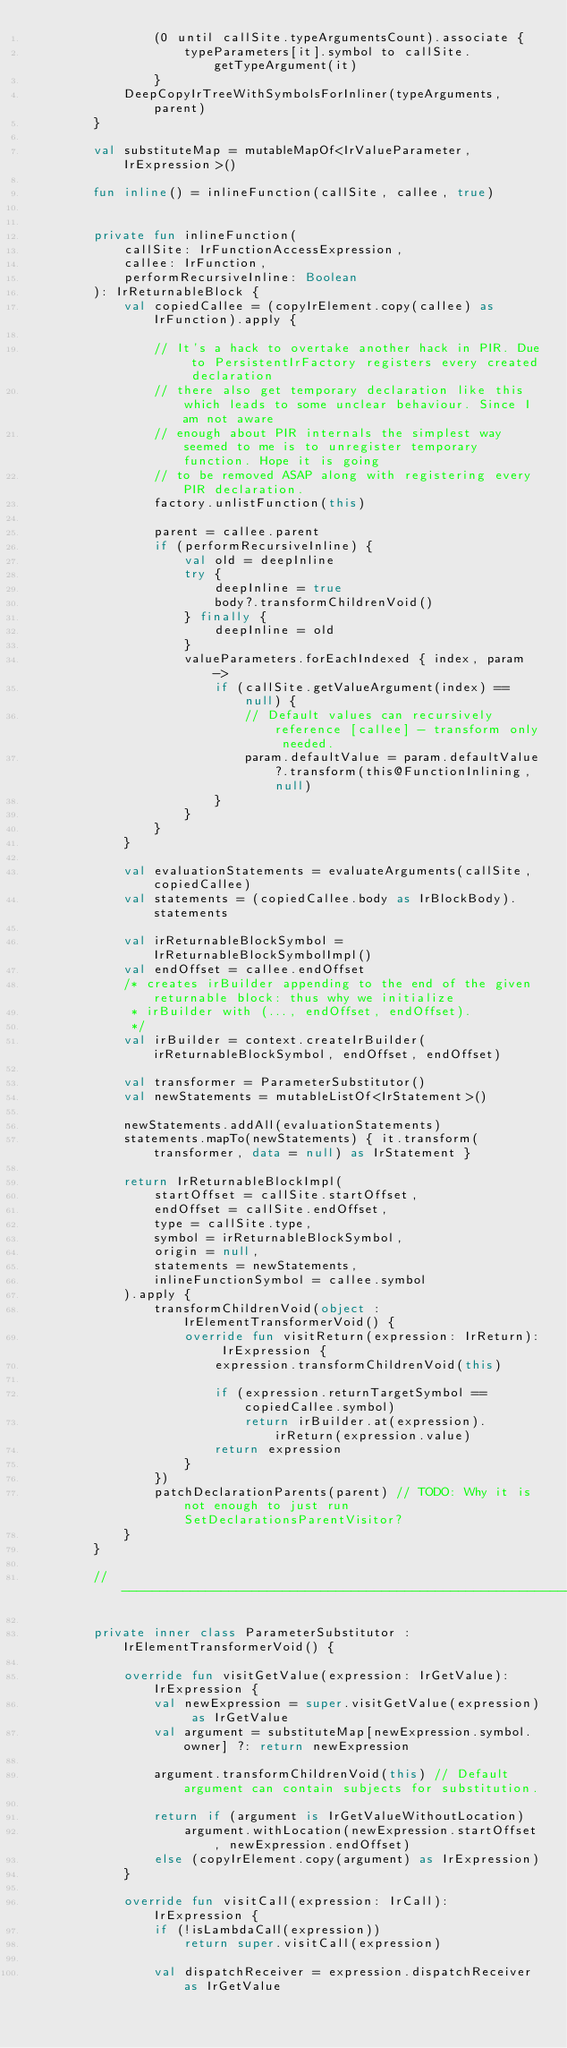Convert code to text. <code><loc_0><loc_0><loc_500><loc_500><_Kotlin_>                (0 until callSite.typeArgumentsCount).associate {
                    typeParameters[it].symbol to callSite.getTypeArgument(it)
                }
            DeepCopyIrTreeWithSymbolsForInliner(typeArguments, parent)
        }

        val substituteMap = mutableMapOf<IrValueParameter, IrExpression>()

        fun inline() = inlineFunction(callSite, callee, true)


        private fun inlineFunction(
            callSite: IrFunctionAccessExpression,
            callee: IrFunction,
            performRecursiveInline: Boolean
        ): IrReturnableBlock {
            val copiedCallee = (copyIrElement.copy(callee) as IrFunction).apply {

                // It's a hack to overtake another hack in PIR. Due to PersistentIrFactory registers every created declaration
                // there also get temporary declaration like this which leads to some unclear behaviour. Since I am not aware
                // enough about PIR internals the simplest way seemed to me is to unregister temporary function. Hope it is going
                // to be removed ASAP along with registering every PIR declaration.
                factory.unlistFunction(this)

                parent = callee.parent
                if (performRecursiveInline) {
                    val old = deepInline
                    try {
                        deepInline = true
                        body?.transformChildrenVoid()
                    } finally {
                        deepInline = old
                    }
                    valueParameters.forEachIndexed { index, param ->
                        if (callSite.getValueArgument(index) == null) {
                            // Default values can recursively reference [callee] - transform only needed.
                            param.defaultValue = param.defaultValue?.transform(this@FunctionInlining, null)
                        }
                    }
                }
            }

            val evaluationStatements = evaluateArguments(callSite, copiedCallee)
            val statements = (copiedCallee.body as IrBlockBody).statements

            val irReturnableBlockSymbol = IrReturnableBlockSymbolImpl()
            val endOffset = callee.endOffset
            /* creates irBuilder appending to the end of the given returnable block: thus why we initialize
             * irBuilder with (..., endOffset, endOffset).
             */
            val irBuilder = context.createIrBuilder(irReturnableBlockSymbol, endOffset, endOffset)

            val transformer = ParameterSubstitutor()
            val newStatements = mutableListOf<IrStatement>()

            newStatements.addAll(evaluationStatements)
            statements.mapTo(newStatements) { it.transform(transformer, data = null) as IrStatement }

            return IrReturnableBlockImpl(
                startOffset = callSite.startOffset,
                endOffset = callSite.endOffset,
                type = callSite.type,
                symbol = irReturnableBlockSymbol,
                origin = null,
                statements = newStatements,
                inlineFunctionSymbol = callee.symbol
            ).apply {
                transformChildrenVoid(object : IrElementTransformerVoid() {
                    override fun visitReturn(expression: IrReturn): IrExpression {
                        expression.transformChildrenVoid(this)

                        if (expression.returnTargetSymbol == copiedCallee.symbol)
                            return irBuilder.at(expression).irReturn(expression.value)
                        return expression
                    }
                })
                patchDeclarationParents(parent) // TODO: Why it is not enough to just run SetDeclarationsParentVisitor?
            }
        }

        //---------------------------------------------------------------------//

        private inner class ParameterSubstitutor : IrElementTransformerVoid() {

            override fun visitGetValue(expression: IrGetValue): IrExpression {
                val newExpression = super.visitGetValue(expression) as IrGetValue
                val argument = substituteMap[newExpression.symbol.owner] ?: return newExpression

                argument.transformChildrenVoid(this) // Default argument can contain subjects for substitution.

                return if (argument is IrGetValueWithoutLocation)
                    argument.withLocation(newExpression.startOffset, newExpression.endOffset)
                else (copyIrElement.copy(argument) as IrExpression)
            }

            override fun visitCall(expression: IrCall): IrExpression {
                if (!isLambdaCall(expression))
                    return super.visitCall(expression)

                val dispatchReceiver = expression.dispatchReceiver as IrGetValue</code> 